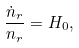<formula> <loc_0><loc_0><loc_500><loc_500>\frac { \dot { n } _ { r } } { n _ { r } } = H _ { 0 } ,</formula> 